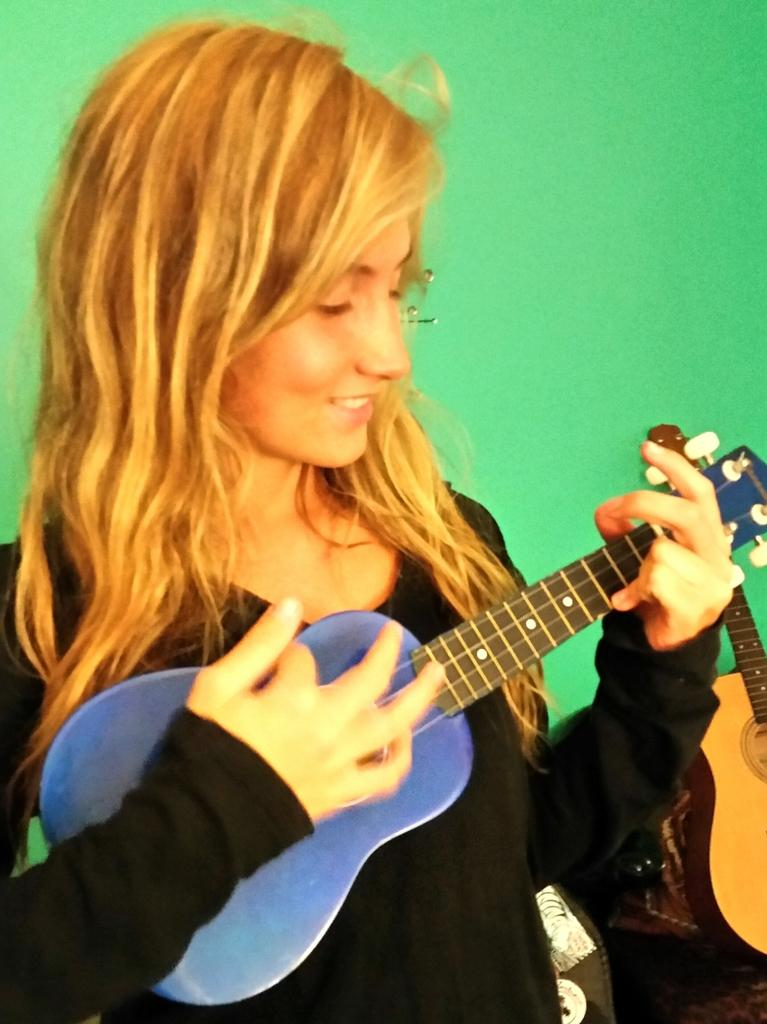What is: Who is the main subject in the image? There is a woman in the image. What is the woman doing in the image? The woman is standing and holding a musical instrument in her hand. What is the woman's facial expression in the image? The woman is smiling in the image. What can be seen in the background of the image? There is a green color wall in the background of the image. Can you see a bridge in the image? No, there is no bridge present in the image. Is the woman playing in the snow in the image? No, there is no snow present in the image. 